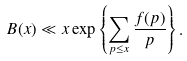Convert formula to latex. <formula><loc_0><loc_0><loc_500><loc_500>B ( x ) \ll x \exp \left \{ \sum _ { p \leq x } \frac { f ( p ) } { p } \right \} .</formula> 